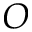Convert formula to latex. <formula><loc_0><loc_0><loc_500><loc_500>O</formula> 